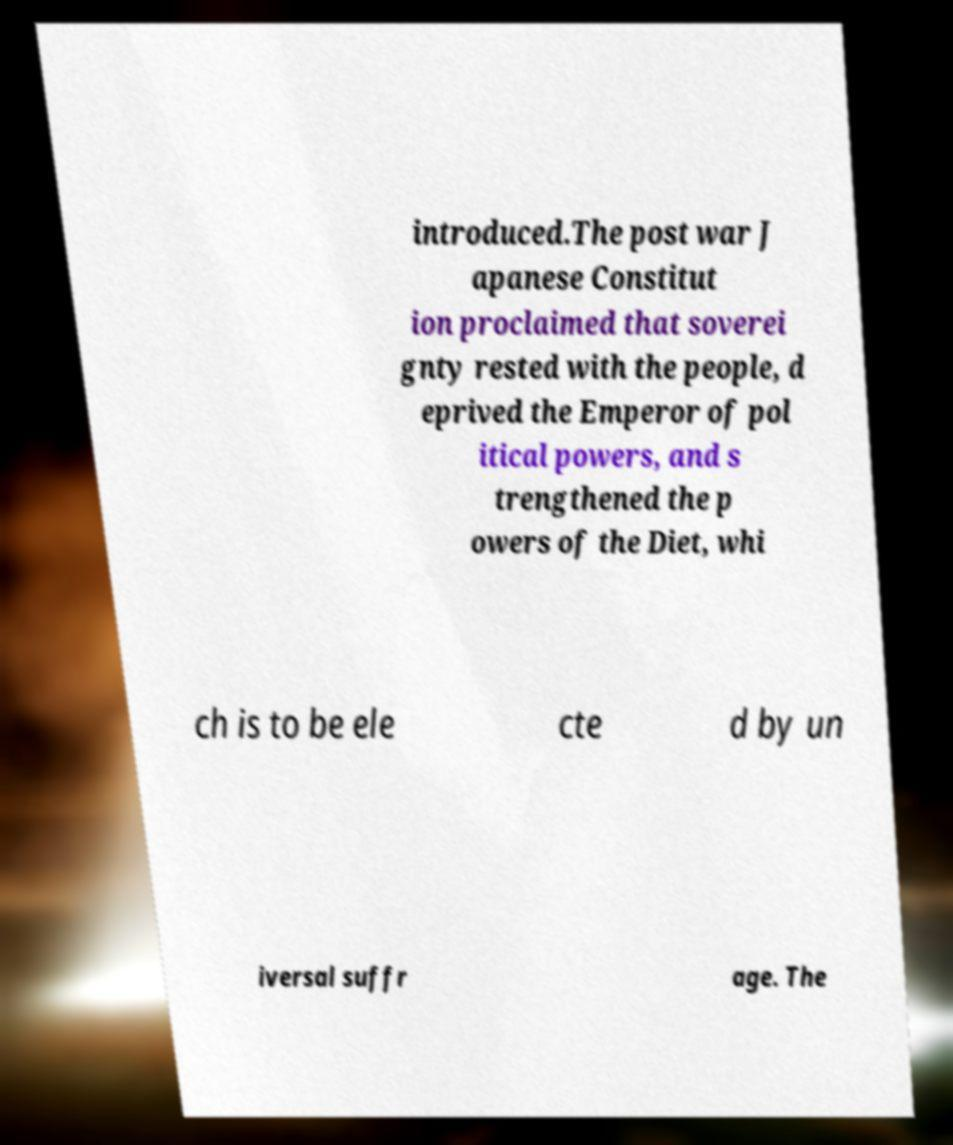What messages or text are displayed in this image? I need them in a readable, typed format. introduced.The post war J apanese Constitut ion proclaimed that soverei gnty rested with the people, d eprived the Emperor of pol itical powers, and s trengthened the p owers of the Diet, whi ch is to be ele cte d by un iversal suffr age. The 